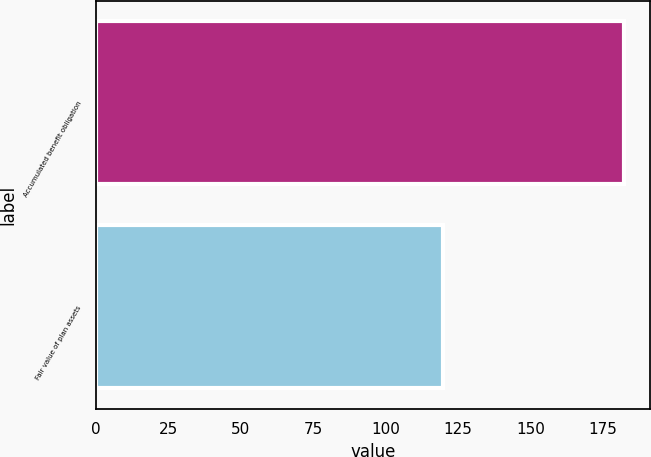Convert chart to OTSL. <chart><loc_0><loc_0><loc_500><loc_500><bar_chart><fcel>Accumulated benefit obligation<fcel>Fair value of plan assets<nl><fcel>182.1<fcel>119.9<nl></chart> 